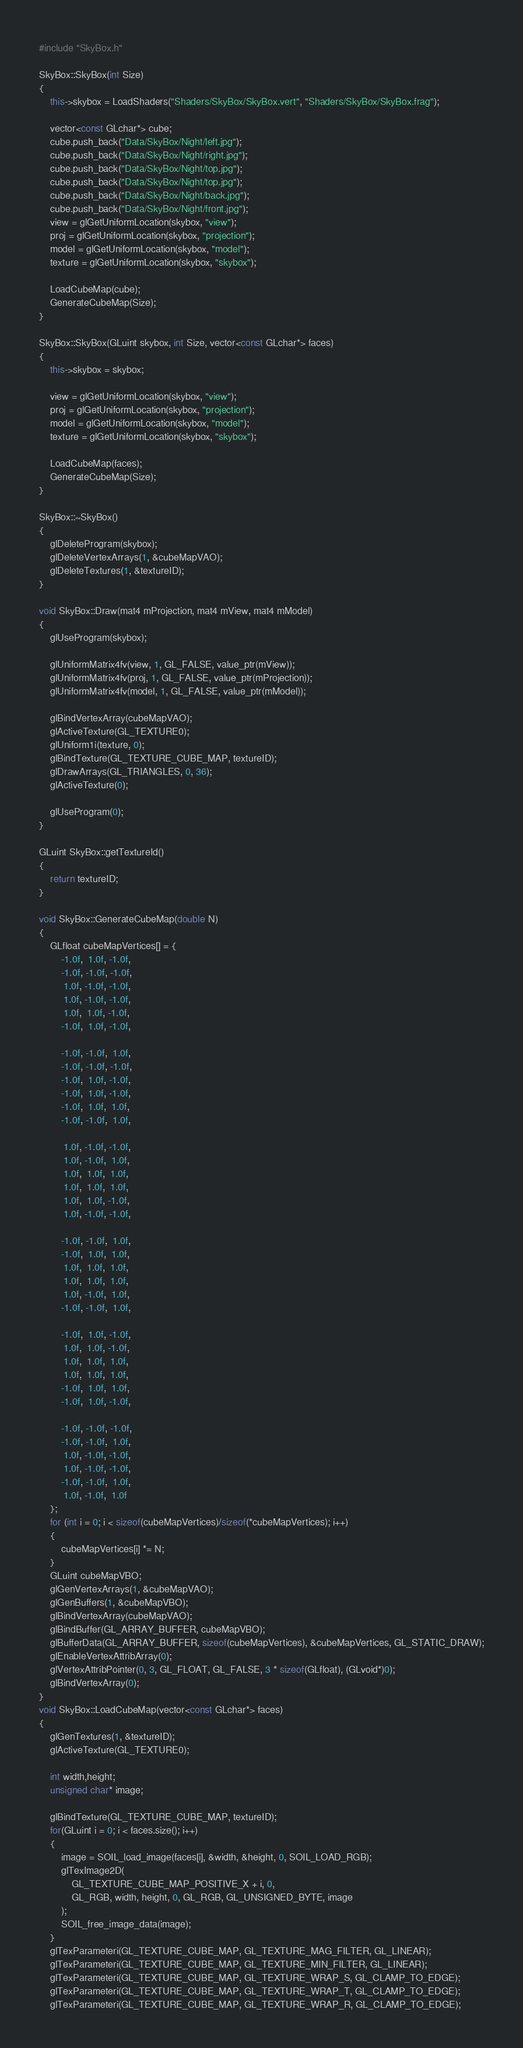Convert code to text. <code><loc_0><loc_0><loc_500><loc_500><_C++_>#include "SkyBox.h"

SkyBox::SkyBox(int Size)
{
	this->skybox = LoadShaders("Shaders/SkyBox/SkyBox.vert", "Shaders/SkyBox/SkyBox.frag");

	vector<const GLchar*> cube;
	cube.push_back("Data/SkyBox/Night/left.jpg");
	cube.push_back("Data/SkyBox/Night/right.jpg");
	cube.push_back("Data/SkyBox/Night/top.jpg");
	cube.push_back("Data/SkyBox/Night/top.jpg");
	cube.push_back("Data/SkyBox/Night/back.jpg");
	cube.push_back("Data/SkyBox/Night/front.jpg");
	view = glGetUniformLocation(skybox, "view");
	proj = glGetUniformLocation(skybox, "projection");
	model = glGetUniformLocation(skybox, "model");
	texture = glGetUniformLocation(skybox, "skybox");

	LoadCubeMap(cube);
	GenerateCubeMap(Size);
}

SkyBox::SkyBox(GLuint skybox, int Size, vector<const GLchar*> faces)
{
	this->skybox = skybox;

	view = glGetUniformLocation(skybox, "view");
	proj = glGetUniformLocation(skybox, "projection");
	model = glGetUniformLocation(skybox, "model");
	texture = glGetUniformLocation(skybox, "skybox");

	LoadCubeMap(faces);
	GenerateCubeMap(Size);
}

SkyBox::~SkyBox()
{
	glDeleteProgram(skybox);
	glDeleteVertexArrays(1, &cubeMapVAO);
	glDeleteTextures(1, &textureID);
}

void SkyBox::Draw(mat4 mProjection, mat4 mView, mat4 mModel)
{
	glUseProgram(skybox);	

	glUniformMatrix4fv(view, 1, GL_FALSE, value_ptr(mView));
	glUniformMatrix4fv(proj, 1, GL_FALSE, value_ptr(mProjection));
	glUniformMatrix4fv(model, 1, GL_FALSE, value_ptr(mModel));
	
	glBindVertexArray(cubeMapVAO);
	glActiveTexture(GL_TEXTURE0);
	glUniform1i(texture, 0);
	glBindTexture(GL_TEXTURE_CUBE_MAP, textureID);
	glDrawArrays(GL_TRIANGLES, 0, 36);
	glActiveTexture(0);

	glUseProgram(0);
}

GLuint SkyBox::getTextureId()
{
	return textureID;
}

void SkyBox::GenerateCubeMap(double N)
{
	GLfloat cubeMapVertices[] = {
        -1.0f,  1.0f, -1.0f,
        -1.0f, -1.0f, -1.0f,
         1.0f, -1.0f, -1.0f,
         1.0f, -1.0f, -1.0f,
         1.0f,  1.0f, -1.0f,
        -1.0f,  1.0f, -1.0f,
  
        -1.0f, -1.0f,  1.0f,
        -1.0f, -1.0f, -1.0f,
        -1.0f,  1.0f, -1.0f,
        -1.0f,  1.0f, -1.0f,
        -1.0f,  1.0f,  1.0f,
        -1.0f, -1.0f,  1.0f,
  
         1.0f, -1.0f, -1.0f,
         1.0f, -1.0f,  1.0f,
         1.0f,  1.0f,  1.0f,
         1.0f,  1.0f,  1.0f,
         1.0f,  1.0f, -1.0f,
         1.0f, -1.0f, -1.0f,
   
        -1.0f, -1.0f,  1.0f,
        -1.0f,  1.0f,  1.0f,
         1.0f,  1.0f,  1.0f,
         1.0f,  1.0f,  1.0f,
         1.0f, -1.0f,  1.0f,
        -1.0f, -1.0f,  1.0f,
  
        -1.0f,  1.0f, -1.0f,
         1.0f,  1.0f, -1.0f,
         1.0f,  1.0f,  1.0f,
         1.0f,  1.0f,  1.0f,
        -1.0f,  1.0f,  1.0f,
        -1.0f,  1.0f, -1.0f,
  
        -1.0f, -1.0f, -1.0f,
        -1.0f, -1.0f,  1.0f,
         1.0f, -1.0f, -1.0f,
         1.0f, -1.0f, -1.0f,
        -1.0f, -1.0f,  1.0f,
         1.0f, -1.0f,  1.0f
    };
	for (int i = 0; i < sizeof(cubeMapVertices)/sizeof(*cubeMapVertices); i++)
	{
		cubeMapVertices[i] *= N;
	}
	GLuint cubeMapVBO;
    glGenVertexArrays(1, &cubeMapVAO);
    glGenBuffers(1, &cubeMapVBO);
    glBindVertexArray(cubeMapVAO);
    glBindBuffer(GL_ARRAY_BUFFER, cubeMapVBO);
    glBufferData(GL_ARRAY_BUFFER, sizeof(cubeMapVertices), &cubeMapVertices, GL_STATIC_DRAW);
    glEnableVertexAttribArray(0);
    glVertexAttribPointer(0, 3, GL_FLOAT, GL_FALSE, 3 * sizeof(GLfloat), (GLvoid*)0);
    glBindVertexArray(0);
}
void SkyBox::LoadCubeMap(vector<const GLchar*> faces)
{
    glGenTextures(1, &textureID);
    glActiveTexture(GL_TEXTURE0);

    int width,height;
    unsigned char* image;
	
    glBindTexture(GL_TEXTURE_CUBE_MAP, textureID);
    for(GLuint i = 0; i < faces.size(); i++)
    {
        image = SOIL_load_image(faces[i], &width, &height, 0, SOIL_LOAD_RGB);
        glTexImage2D(
            GL_TEXTURE_CUBE_MAP_POSITIVE_X + i, 0,
            GL_RGB, width, height, 0, GL_RGB, GL_UNSIGNED_BYTE, image
        );
		SOIL_free_image_data(image);
    }
    glTexParameteri(GL_TEXTURE_CUBE_MAP, GL_TEXTURE_MAG_FILTER, GL_LINEAR);
    glTexParameteri(GL_TEXTURE_CUBE_MAP, GL_TEXTURE_MIN_FILTER, GL_LINEAR);
    glTexParameteri(GL_TEXTURE_CUBE_MAP, GL_TEXTURE_WRAP_S, GL_CLAMP_TO_EDGE);
    glTexParameteri(GL_TEXTURE_CUBE_MAP, GL_TEXTURE_WRAP_T, GL_CLAMP_TO_EDGE);
    glTexParameteri(GL_TEXTURE_CUBE_MAP, GL_TEXTURE_WRAP_R, GL_CLAMP_TO_EDGE);</code> 